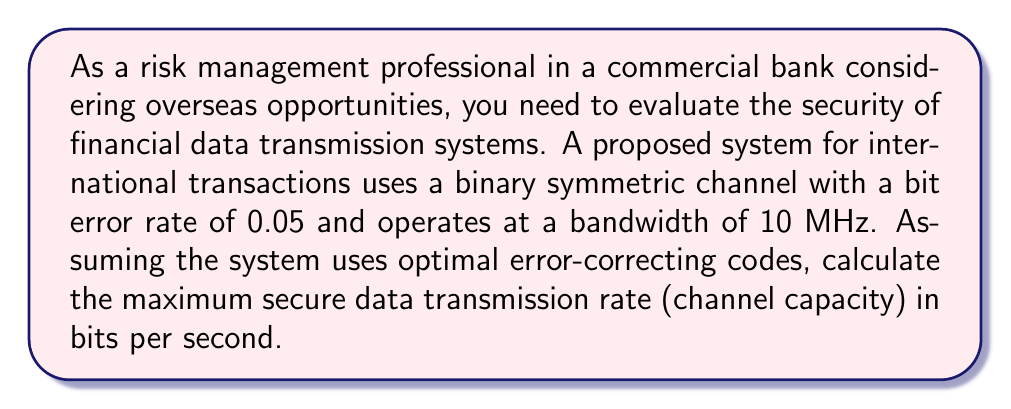Provide a solution to this math problem. To solve this problem, we'll use the Shannon-Hartley theorem for channel capacity in a binary symmetric channel (BSC). The steps are as follows:

1) For a BSC, the channel capacity is given by:

   $$C = W \cdot (1 + p \log_2 p + (1-p) \log_2 (1-p))$$

   Where:
   $C$ is the channel capacity in bits per second
   $W$ is the bandwidth in Hz
   $p$ is the bit error rate

2) We're given:
   $W = 10 \text{ MHz} = 10 \times 10^6 \text{ Hz}$
   $p = 0.05$

3) Let's calculate the term inside the parentheses:

   $$1 + p \log_2 p + (1-p) \log_2 (1-p)$$
   $$= 1 + 0.05 \log_2 0.05 + 0.95 \log_2 0.95$$

4) Calculate each logarithm:
   $\log_2 0.05 \approx -4.32193$
   $\log_2 0.95 \approx -0.07406$

5) Substitute these values:

   $$1 + 0.05(-4.32193) + 0.95(-0.07406)$$
   $$= 1 - 0.21610 - 0.07036$$
   $$= 0.71354$$

6) Now, multiply by the bandwidth:

   $$C = 10 \times 10^6 \times 0.71354$$
   $$= 7,135,400 \text{ bits per second}$$
   $$\approx 7.1354 \text{ Mbps}$$

This represents the maximum secure data transmission rate for the given system.
Answer: The channel capacity is approximately 7.1354 Mbps (7,135,400 bits per second). 